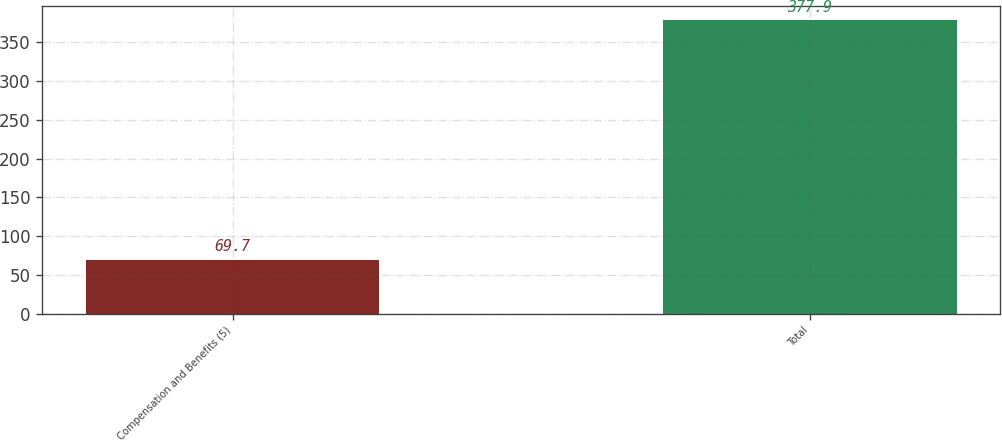Convert chart to OTSL. <chart><loc_0><loc_0><loc_500><loc_500><bar_chart><fcel>Compensation and Benefits (5)<fcel>Total<nl><fcel>69.7<fcel>377.9<nl></chart> 